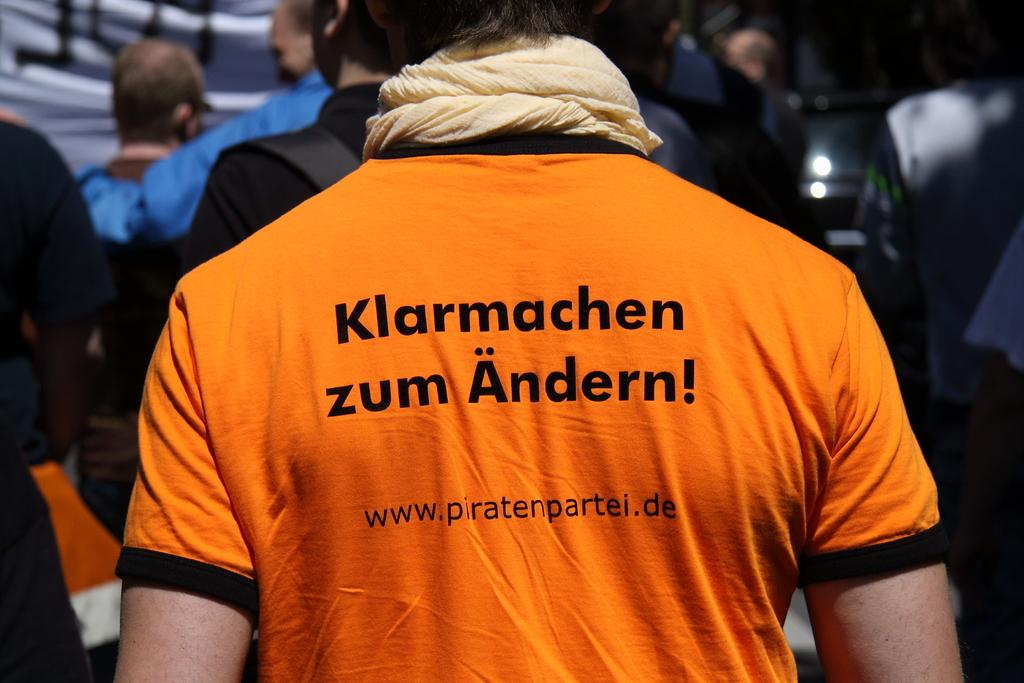Provide a one-sentence caption for the provided image. A man wearing an orange shirt with the letter w on it. 